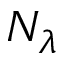<formula> <loc_0><loc_0><loc_500><loc_500>N _ { \lambda }</formula> 